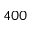<formula> <loc_0><loc_0><loc_500><loc_500>4 0 0</formula> 